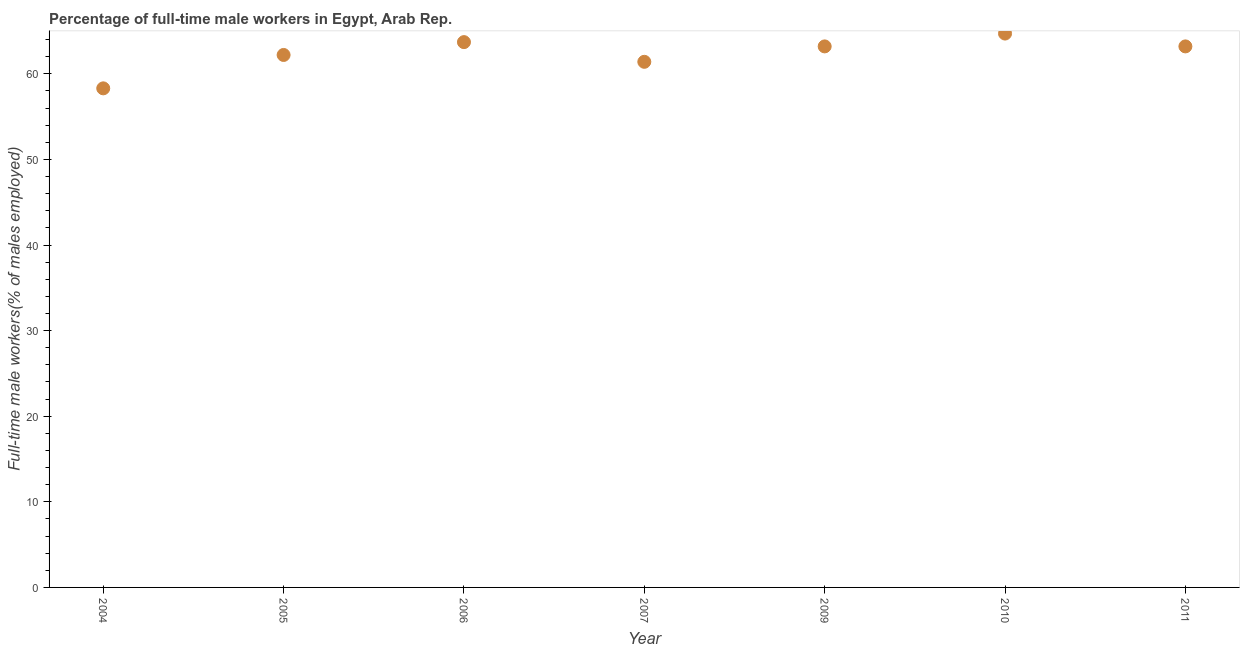What is the percentage of full-time male workers in 2011?
Your answer should be very brief. 63.2. Across all years, what is the maximum percentage of full-time male workers?
Offer a terse response. 64.7. Across all years, what is the minimum percentage of full-time male workers?
Your response must be concise. 58.3. What is the sum of the percentage of full-time male workers?
Keep it short and to the point. 436.7. What is the difference between the percentage of full-time male workers in 2006 and 2010?
Make the answer very short. -1. What is the average percentage of full-time male workers per year?
Your response must be concise. 62.39. What is the median percentage of full-time male workers?
Your answer should be compact. 63.2. What is the ratio of the percentage of full-time male workers in 2004 to that in 2009?
Provide a succinct answer. 0.92. Is the percentage of full-time male workers in 2004 less than that in 2011?
Offer a very short reply. Yes. What is the difference between the highest and the second highest percentage of full-time male workers?
Your answer should be very brief. 1. What is the difference between the highest and the lowest percentage of full-time male workers?
Your answer should be compact. 6.4. How many years are there in the graph?
Make the answer very short. 7. What is the difference between two consecutive major ticks on the Y-axis?
Your answer should be compact. 10. Does the graph contain grids?
Provide a short and direct response. No. What is the title of the graph?
Your answer should be compact. Percentage of full-time male workers in Egypt, Arab Rep. What is the label or title of the Y-axis?
Give a very brief answer. Full-time male workers(% of males employed). What is the Full-time male workers(% of males employed) in 2004?
Keep it short and to the point. 58.3. What is the Full-time male workers(% of males employed) in 2005?
Your response must be concise. 62.2. What is the Full-time male workers(% of males employed) in 2006?
Your response must be concise. 63.7. What is the Full-time male workers(% of males employed) in 2007?
Ensure brevity in your answer.  61.4. What is the Full-time male workers(% of males employed) in 2009?
Offer a terse response. 63.2. What is the Full-time male workers(% of males employed) in 2010?
Make the answer very short. 64.7. What is the Full-time male workers(% of males employed) in 2011?
Make the answer very short. 63.2. What is the difference between the Full-time male workers(% of males employed) in 2004 and 2005?
Your response must be concise. -3.9. What is the difference between the Full-time male workers(% of males employed) in 2004 and 2006?
Your answer should be compact. -5.4. What is the difference between the Full-time male workers(% of males employed) in 2004 and 2009?
Make the answer very short. -4.9. What is the difference between the Full-time male workers(% of males employed) in 2004 and 2010?
Ensure brevity in your answer.  -6.4. What is the difference between the Full-time male workers(% of males employed) in 2005 and 2006?
Keep it short and to the point. -1.5. What is the difference between the Full-time male workers(% of males employed) in 2006 and 2011?
Your answer should be very brief. 0.5. What is the difference between the Full-time male workers(% of males employed) in 2007 and 2011?
Provide a short and direct response. -1.8. What is the difference between the Full-time male workers(% of males employed) in 2009 and 2010?
Make the answer very short. -1.5. What is the difference between the Full-time male workers(% of males employed) in 2009 and 2011?
Provide a short and direct response. 0. What is the difference between the Full-time male workers(% of males employed) in 2010 and 2011?
Your answer should be very brief. 1.5. What is the ratio of the Full-time male workers(% of males employed) in 2004 to that in 2005?
Keep it short and to the point. 0.94. What is the ratio of the Full-time male workers(% of males employed) in 2004 to that in 2006?
Offer a terse response. 0.92. What is the ratio of the Full-time male workers(% of males employed) in 2004 to that in 2007?
Offer a very short reply. 0.95. What is the ratio of the Full-time male workers(% of males employed) in 2004 to that in 2009?
Ensure brevity in your answer.  0.92. What is the ratio of the Full-time male workers(% of males employed) in 2004 to that in 2010?
Give a very brief answer. 0.9. What is the ratio of the Full-time male workers(% of males employed) in 2004 to that in 2011?
Offer a terse response. 0.92. What is the ratio of the Full-time male workers(% of males employed) in 2005 to that in 2006?
Make the answer very short. 0.98. What is the ratio of the Full-time male workers(% of males employed) in 2005 to that in 2010?
Offer a very short reply. 0.96. What is the ratio of the Full-time male workers(% of males employed) in 2005 to that in 2011?
Give a very brief answer. 0.98. What is the ratio of the Full-time male workers(% of males employed) in 2006 to that in 2011?
Your answer should be compact. 1.01. What is the ratio of the Full-time male workers(% of males employed) in 2007 to that in 2009?
Give a very brief answer. 0.97. What is the ratio of the Full-time male workers(% of males employed) in 2007 to that in 2010?
Offer a very short reply. 0.95. What is the ratio of the Full-time male workers(% of males employed) in 2007 to that in 2011?
Make the answer very short. 0.97. What is the ratio of the Full-time male workers(% of males employed) in 2009 to that in 2010?
Provide a succinct answer. 0.98. What is the ratio of the Full-time male workers(% of males employed) in 2009 to that in 2011?
Ensure brevity in your answer.  1. 